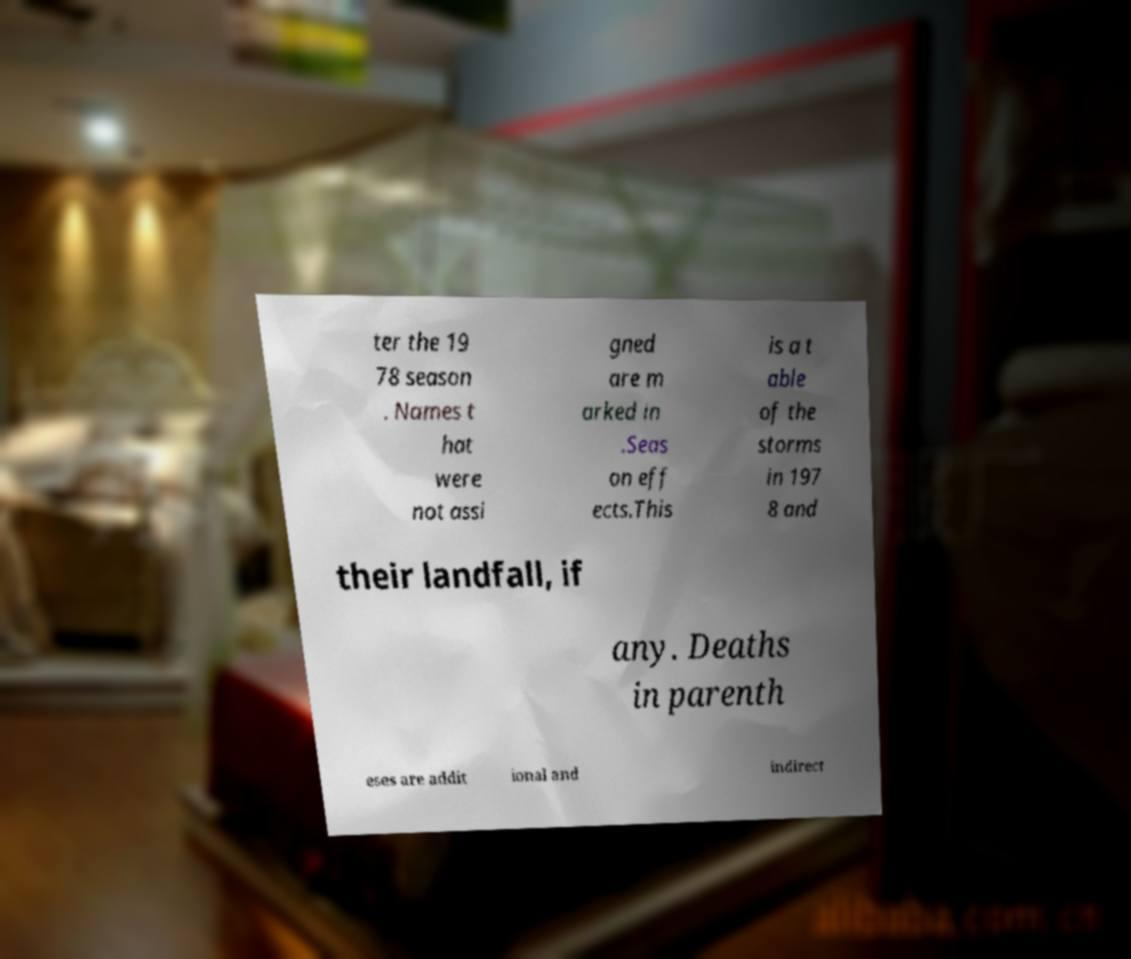Could you assist in decoding the text presented in this image and type it out clearly? ter the 19 78 season . Names t hat were not assi gned are m arked in .Seas on eff ects.This is a t able of the storms in 197 8 and their landfall, if any. Deaths in parenth eses are addit ional and indirect 